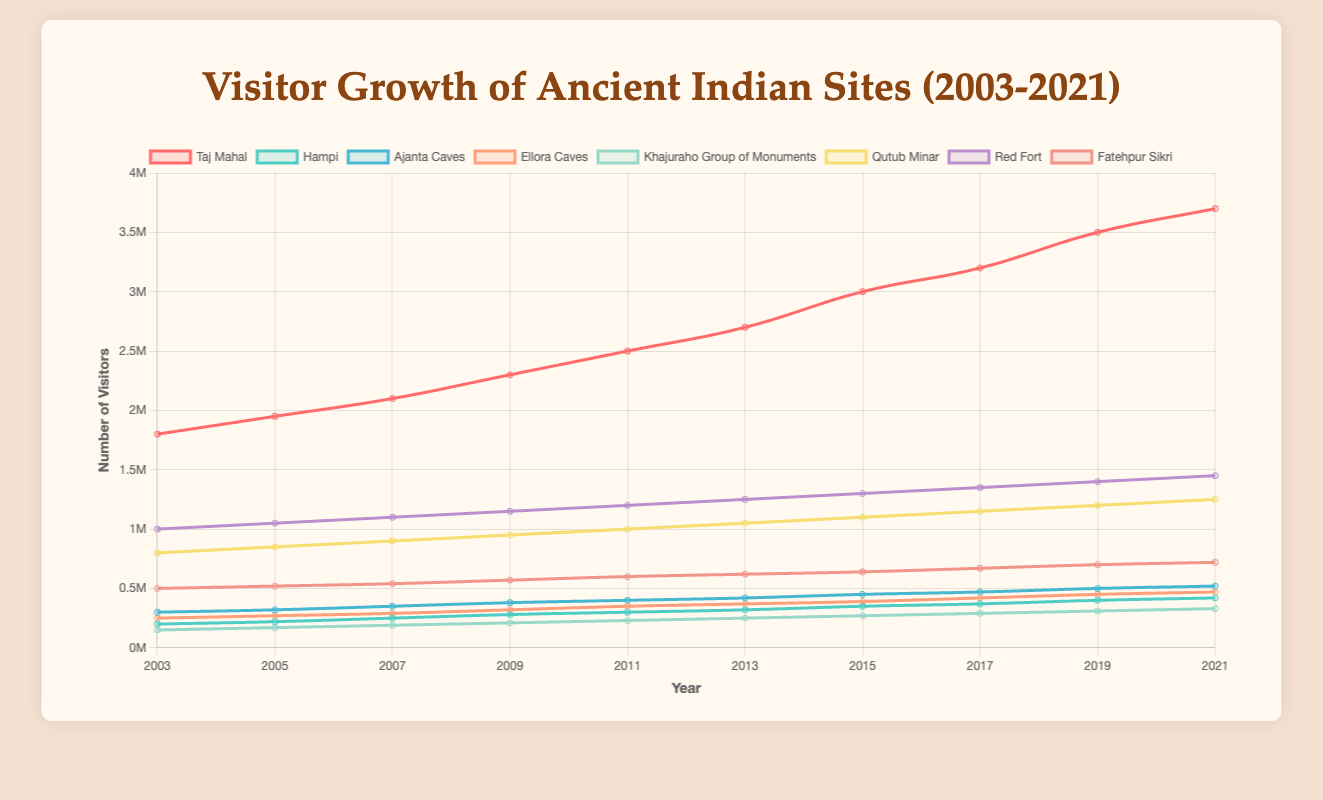What's the site with the highest visitor growth between 2003 and 2021? First, identify the visitor number for each site in 2003 and 2021. Calculate the difference for each site. The site with the largest increase is the Taj Mahal, which grew from 1,800,000 visitors in 2003 to 3,700,000 visitors in 2021, resulting in a growth of 1,900,000 visitors.
Answer: Taj Mahal Which site had the least number of visitors in 2021? Examine the visitor numbers for all sites in 2021 to find the minimum value. Khajuraho Group of Monuments had 330,000 visitors in 2021, which is the lowest among all sites.
Answer: Khajuraho Group of Monuments What is the average number of visitors to the Red Fort for the provided years? Add the visitor numbers for the Red Fort from 2003 to 2021 and divide by the number of years (10). The sum of the visitor numbers is 1,000,000 + 1,050,000 + 1,100,000 + 1,150,000 + 1,200,000 + 1,250,000 + 1,300,000 + 1,350,000 + 1,400,000 + 1,450,000 = 11,250,000. Dividing by 10 gives an average of 1,125,000 visitors.
Answer: 1,125,000 Compare the visitor trend of the Taj Mahal and Qutub Minar. Which site shows a steeper increase? By visually comparing the slope of the lines representing the Taj Mahal and Qutub Minar in the plot, the Taj Mahal shows a steeper increase over the years, as evidenced by its larger growth from 1,800,000 to 3,700,000 visitors compared to Qutub Minar's growth from 800,000 to 1,250,000 visitors.
Answer: Taj Mahal What is the total number of visitors for all sites in 2019? Sum the visitor numbers for all sites in 2019: 3,500,000 (Taj Mahal) + 400,000 (Hampi) + 500,000 (Ajanta Caves) + 450,000 (Ellora Caves) + 310,000 (Khajuraho Group of Monuments) + 1,200,000 (Qutub Minar) + 1,400,000 (Red Fort) + 700,000 (Fatehpur Sikri) = 8,460,000 visitors.
Answer: 8,460,000 Which site had the least growth in visitor numbers between 2003 and 2021? Calculate the growth for each site from 2003 to 2021. Hampi grew from 200,000 to 420,000, resulting in a growth of 220,000 visitors, which is the least among all sites.
Answer: Hampi What is the average annual growth rate of visitors for the Taj Mahal? Calculate the total growth (3,700,000 - 1,800,000 = 1,900,000) and divide by the number of years (2021 - 2003 = 18). The average annual growth rate is 1,900,000 / 18 = 105,556 visitors per year.
Answer: 105,556 visitors per year Compare the visitor numbers for Ajanta Caves and Ellora Caves in 2015. Which one had more visitors? Check the visitor numbers for both sites in 2015. Ajanta Caves had 450,000 visitors, and Ellora Caves had 390,000 visitors. Ajanta Caves had more visitors.
Answer: Ajanta Caves Identify the site with the highest visitor numbers in 2007. Compare the visitor numbers for all sites in 2007. The Taj Mahal had 2,100,000 visitors, the highest among all sites in that year.
Answer: Taj Mahal 